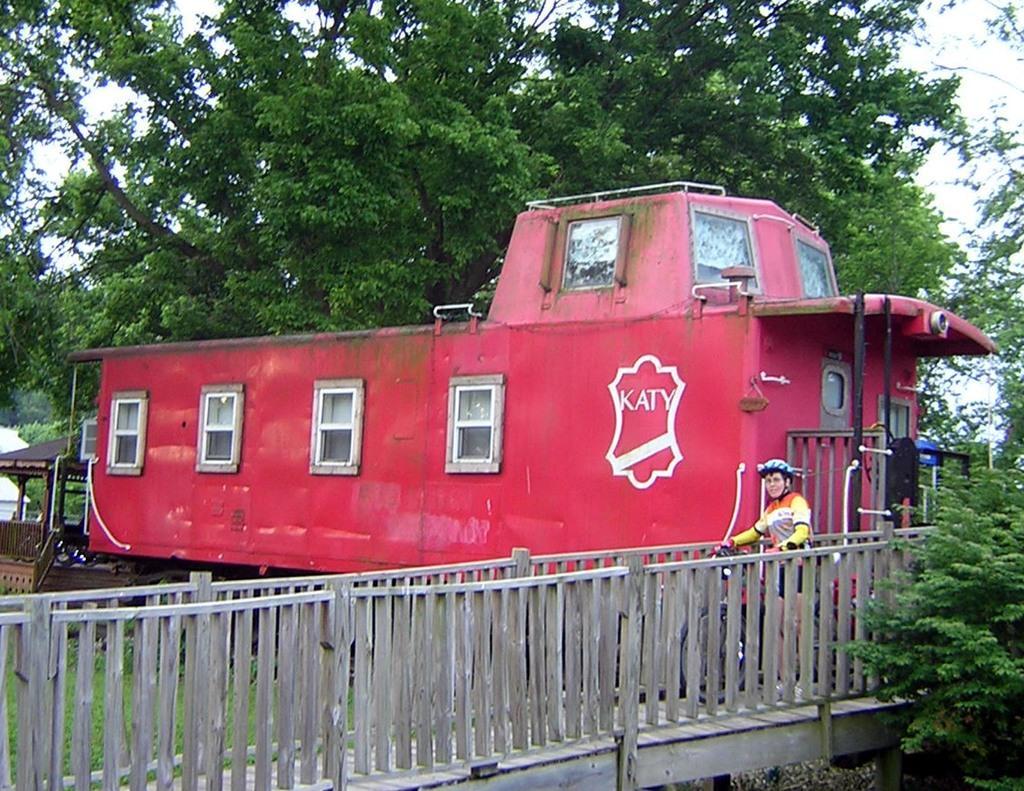Describe this image in one or two sentences. In this image there is a vehicle, person, railings, trees, grass, shelter and objects. Through the trees the sky is visible. 